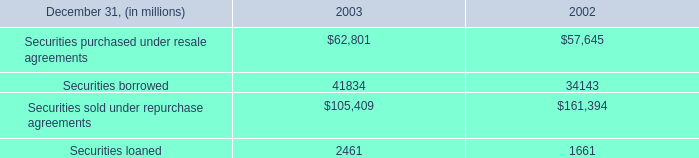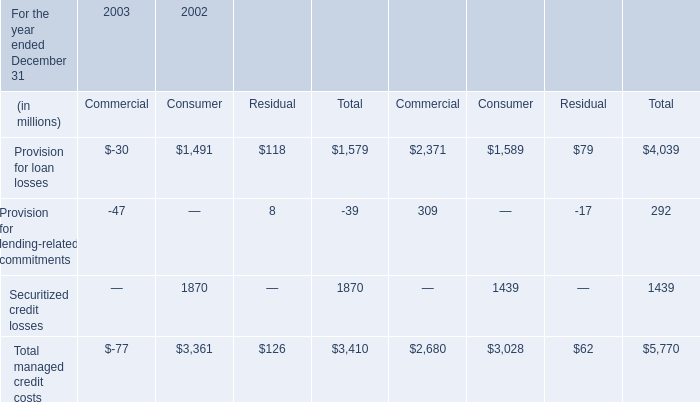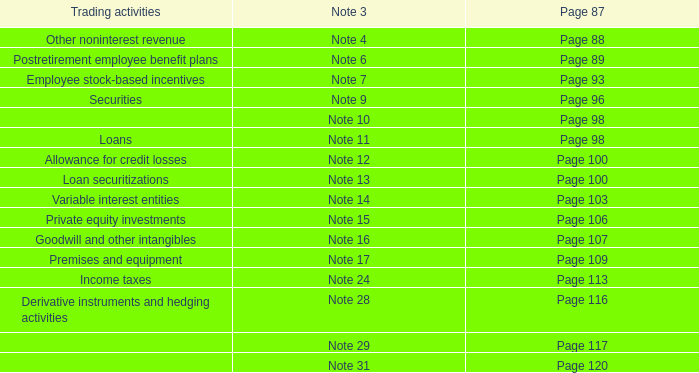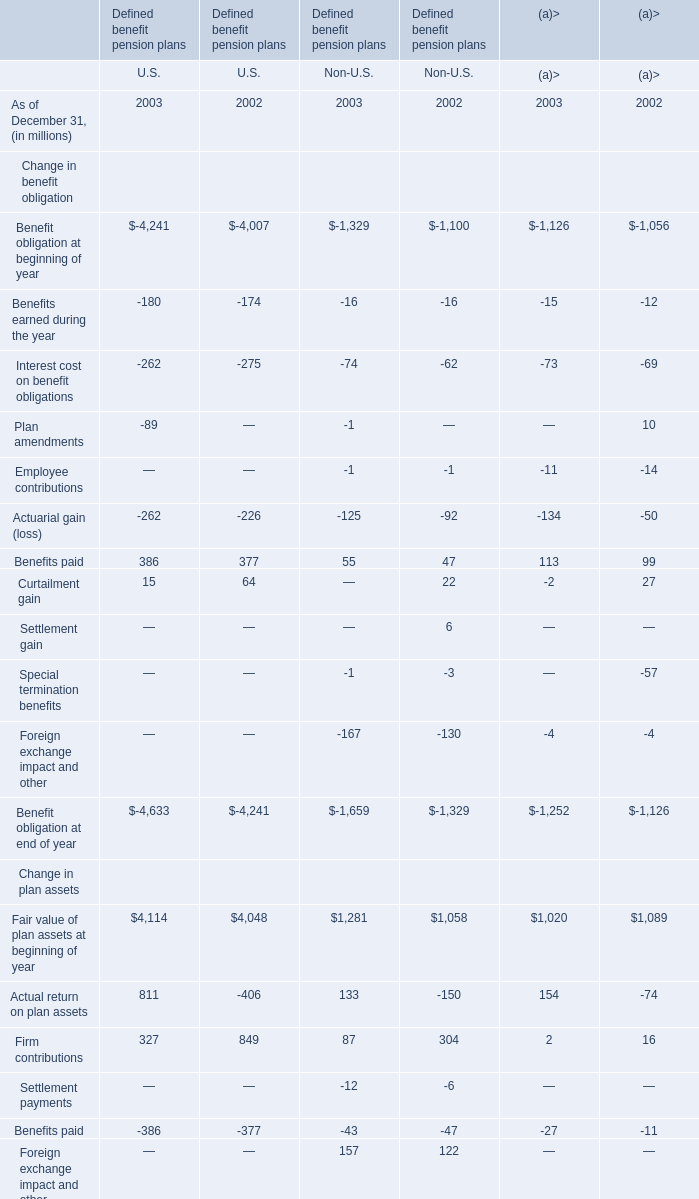what was the consumer expected loss allowance at 12/31/2002 , in billions? 
Computations: (2.3 / ((100 - 4) / 100))
Answer: 2.39583. 